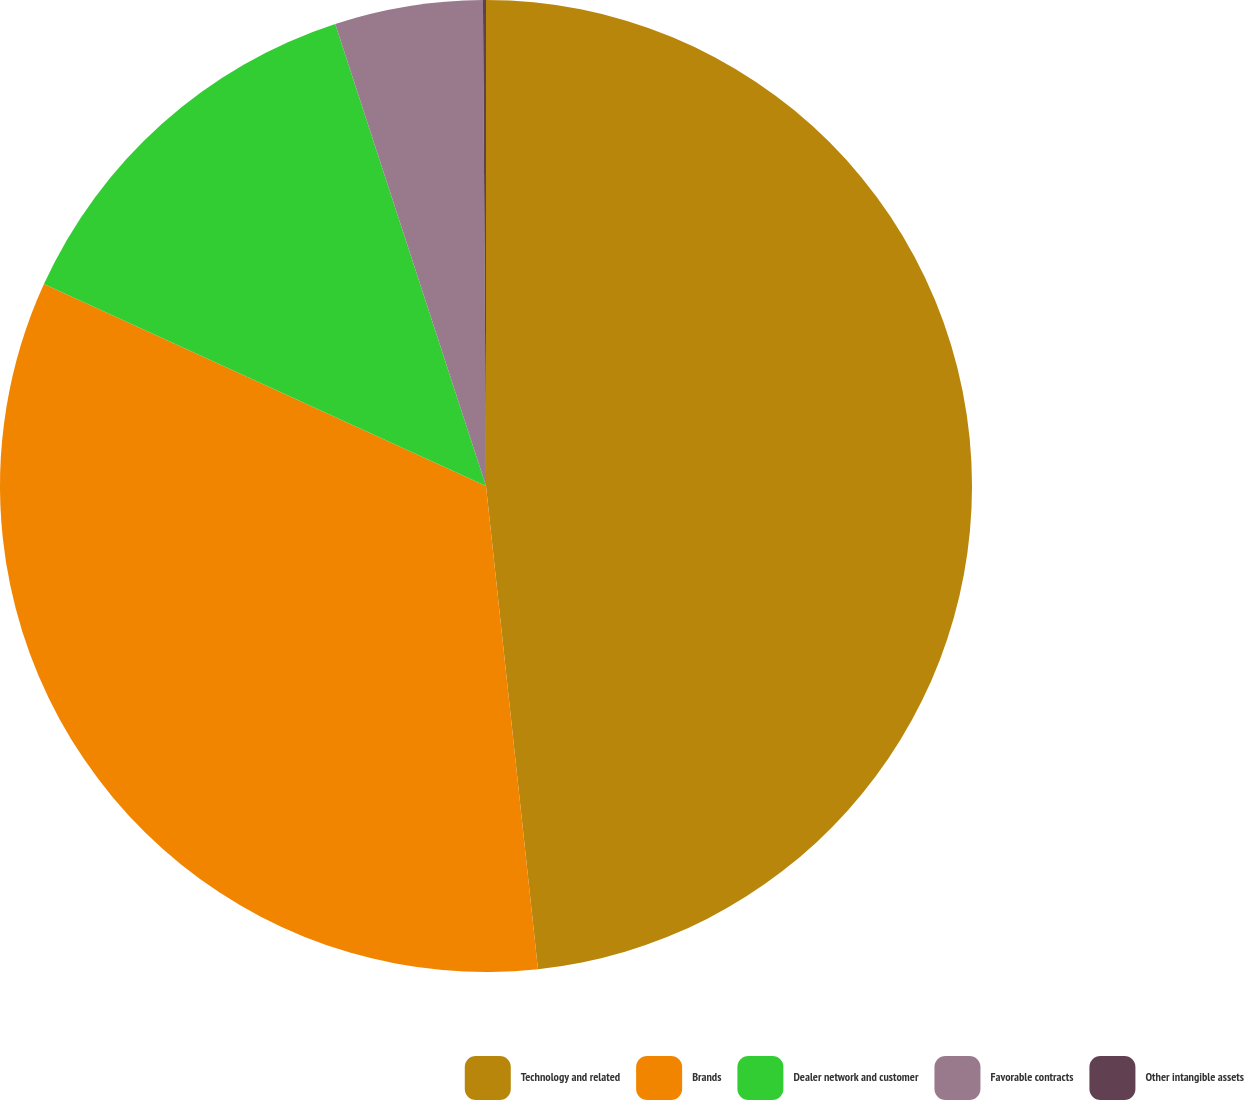Convert chart. <chart><loc_0><loc_0><loc_500><loc_500><pie_chart><fcel>Technology and related<fcel>Brands<fcel>Dealer network and customer<fcel>Favorable contracts<fcel>Other intangible assets<nl><fcel>48.29%<fcel>33.52%<fcel>13.16%<fcel>4.92%<fcel>0.1%<nl></chart> 